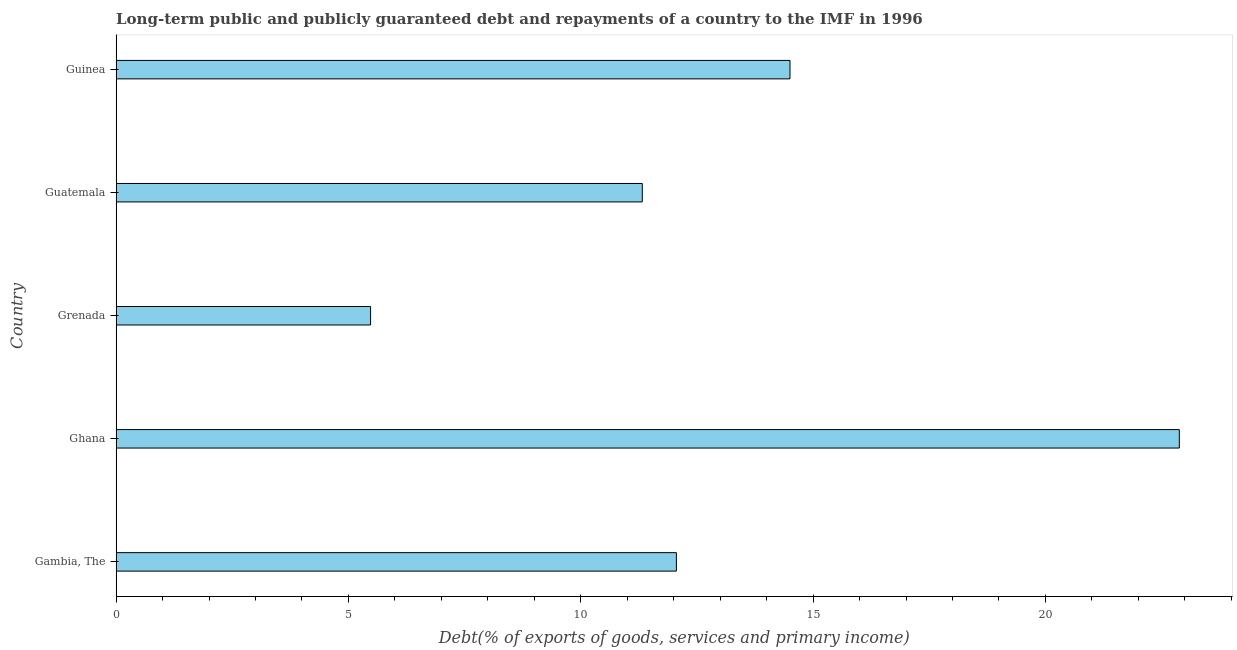Does the graph contain any zero values?
Offer a very short reply. No. What is the title of the graph?
Keep it short and to the point. Long-term public and publicly guaranteed debt and repayments of a country to the IMF in 1996. What is the label or title of the X-axis?
Keep it short and to the point. Debt(% of exports of goods, services and primary income). What is the debt service in Gambia, The?
Give a very brief answer. 12.06. Across all countries, what is the maximum debt service?
Your answer should be very brief. 22.88. Across all countries, what is the minimum debt service?
Keep it short and to the point. 5.48. In which country was the debt service minimum?
Offer a terse response. Grenada. What is the sum of the debt service?
Offer a terse response. 66.24. What is the difference between the debt service in Gambia, The and Ghana?
Make the answer very short. -10.82. What is the average debt service per country?
Provide a short and direct response. 13.25. What is the median debt service?
Provide a short and direct response. 12.06. In how many countries, is the debt service greater than 18 %?
Provide a succinct answer. 1. What is the ratio of the debt service in Grenada to that in Guatemala?
Ensure brevity in your answer.  0.48. Is the debt service in Guatemala less than that in Guinea?
Your answer should be compact. Yes. What is the difference between the highest and the second highest debt service?
Make the answer very short. 8.38. Is the sum of the debt service in Gambia, The and Guatemala greater than the maximum debt service across all countries?
Ensure brevity in your answer.  Yes. What is the difference between the highest and the lowest debt service?
Make the answer very short. 17.41. In how many countries, is the debt service greater than the average debt service taken over all countries?
Give a very brief answer. 2. How many bars are there?
Offer a terse response. 5. What is the Debt(% of exports of goods, services and primary income) of Gambia, The?
Make the answer very short. 12.06. What is the Debt(% of exports of goods, services and primary income) in Ghana?
Provide a short and direct response. 22.88. What is the Debt(% of exports of goods, services and primary income) in Grenada?
Give a very brief answer. 5.48. What is the Debt(% of exports of goods, services and primary income) of Guatemala?
Offer a terse response. 11.32. What is the Debt(% of exports of goods, services and primary income) in Guinea?
Provide a succinct answer. 14.5. What is the difference between the Debt(% of exports of goods, services and primary income) in Gambia, The and Ghana?
Make the answer very short. -10.82. What is the difference between the Debt(% of exports of goods, services and primary income) in Gambia, The and Grenada?
Make the answer very short. 6.58. What is the difference between the Debt(% of exports of goods, services and primary income) in Gambia, The and Guatemala?
Offer a terse response. 0.73. What is the difference between the Debt(% of exports of goods, services and primary income) in Gambia, The and Guinea?
Keep it short and to the point. -2.45. What is the difference between the Debt(% of exports of goods, services and primary income) in Ghana and Grenada?
Keep it short and to the point. 17.41. What is the difference between the Debt(% of exports of goods, services and primary income) in Ghana and Guatemala?
Provide a short and direct response. 11.56. What is the difference between the Debt(% of exports of goods, services and primary income) in Ghana and Guinea?
Offer a very short reply. 8.38. What is the difference between the Debt(% of exports of goods, services and primary income) in Grenada and Guatemala?
Provide a short and direct response. -5.85. What is the difference between the Debt(% of exports of goods, services and primary income) in Grenada and Guinea?
Your answer should be very brief. -9.03. What is the difference between the Debt(% of exports of goods, services and primary income) in Guatemala and Guinea?
Ensure brevity in your answer.  -3.18. What is the ratio of the Debt(% of exports of goods, services and primary income) in Gambia, The to that in Ghana?
Your answer should be very brief. 0.53. What is the ratio of the Debt(% of exports of goods, services and primary income) in Gambia, The to that in Grenada?
Your answer should be very brief. 2.2. What is the ratio of the Debt(% of exports of goods, services and primary income) in Gambia, The to that in Guatemala?
Your answer should be very brief. 1.06. What is the ratio of the Debt(% of exports of goods, services and primary income) in Gambia, The to that in Guinea?
Offer a terse response. 0.83. What is the ratio of the Debt(% of exports of goods, services and primary income) in Ghana to that in Grenada?
Your answer should be compact. 4.18. What is the ratio of the Debt(% of exports of goods, services and primary income) in Ghana to that in Guatemala?
Offer a terse response. 2.02. What is the ratio of the Debt(% of exports of goods, services and primary income) in Ghana to that in Guinea?
Offer a very short reply. 1.58. What is the ratio of the Debt(% of exports of goods, services and primary income) in Grenada to that in Guatemala?
Your answer should be compact. 0.48. What is the ratio of the Debt(% of exports of goods, services and primary income) in Grenada to that in Guinea?
Your answer should be compact. 0.38. What is the ratio of the Debt(% of exports of goods, services and primary income) in Guatemala to that in Guinea?
Offer a terse response. 0.78. 